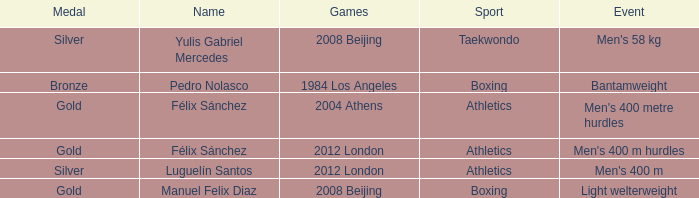Which Medal had a Games of 2008 beijing, and a Sport of taekwondo? Silver. Parse the table in full. {'header': ['Medal', 'Name', 'Games', 'Sport', 'Event'], 'rows': [['Silver', 'Yulis Gabriel Mercedes', '2008 Beijing', 'Taekwondo', "Men's 58 kg"], ['Bronze', 'Pedro Nolasco', '1984 Los Angeles', 'Boxing', 'Bantamweight'], ['Gold', 'Félix Sánchez', '2004 Athens', 'Athletics', "Men's 400 metre hurdles"], ['Gold', 'Félix Sánchez', '2012 London', 'Athletics', "Men's 400 m hurdles"], ['Silver', 'Luguelín Santos', '2012 London', 'Athletics', "Men's 400 m"], ['Gold', 'Manuel Felix Diaz', '2008 Beijing', 'Boxing', 'Light welterweight']]} 